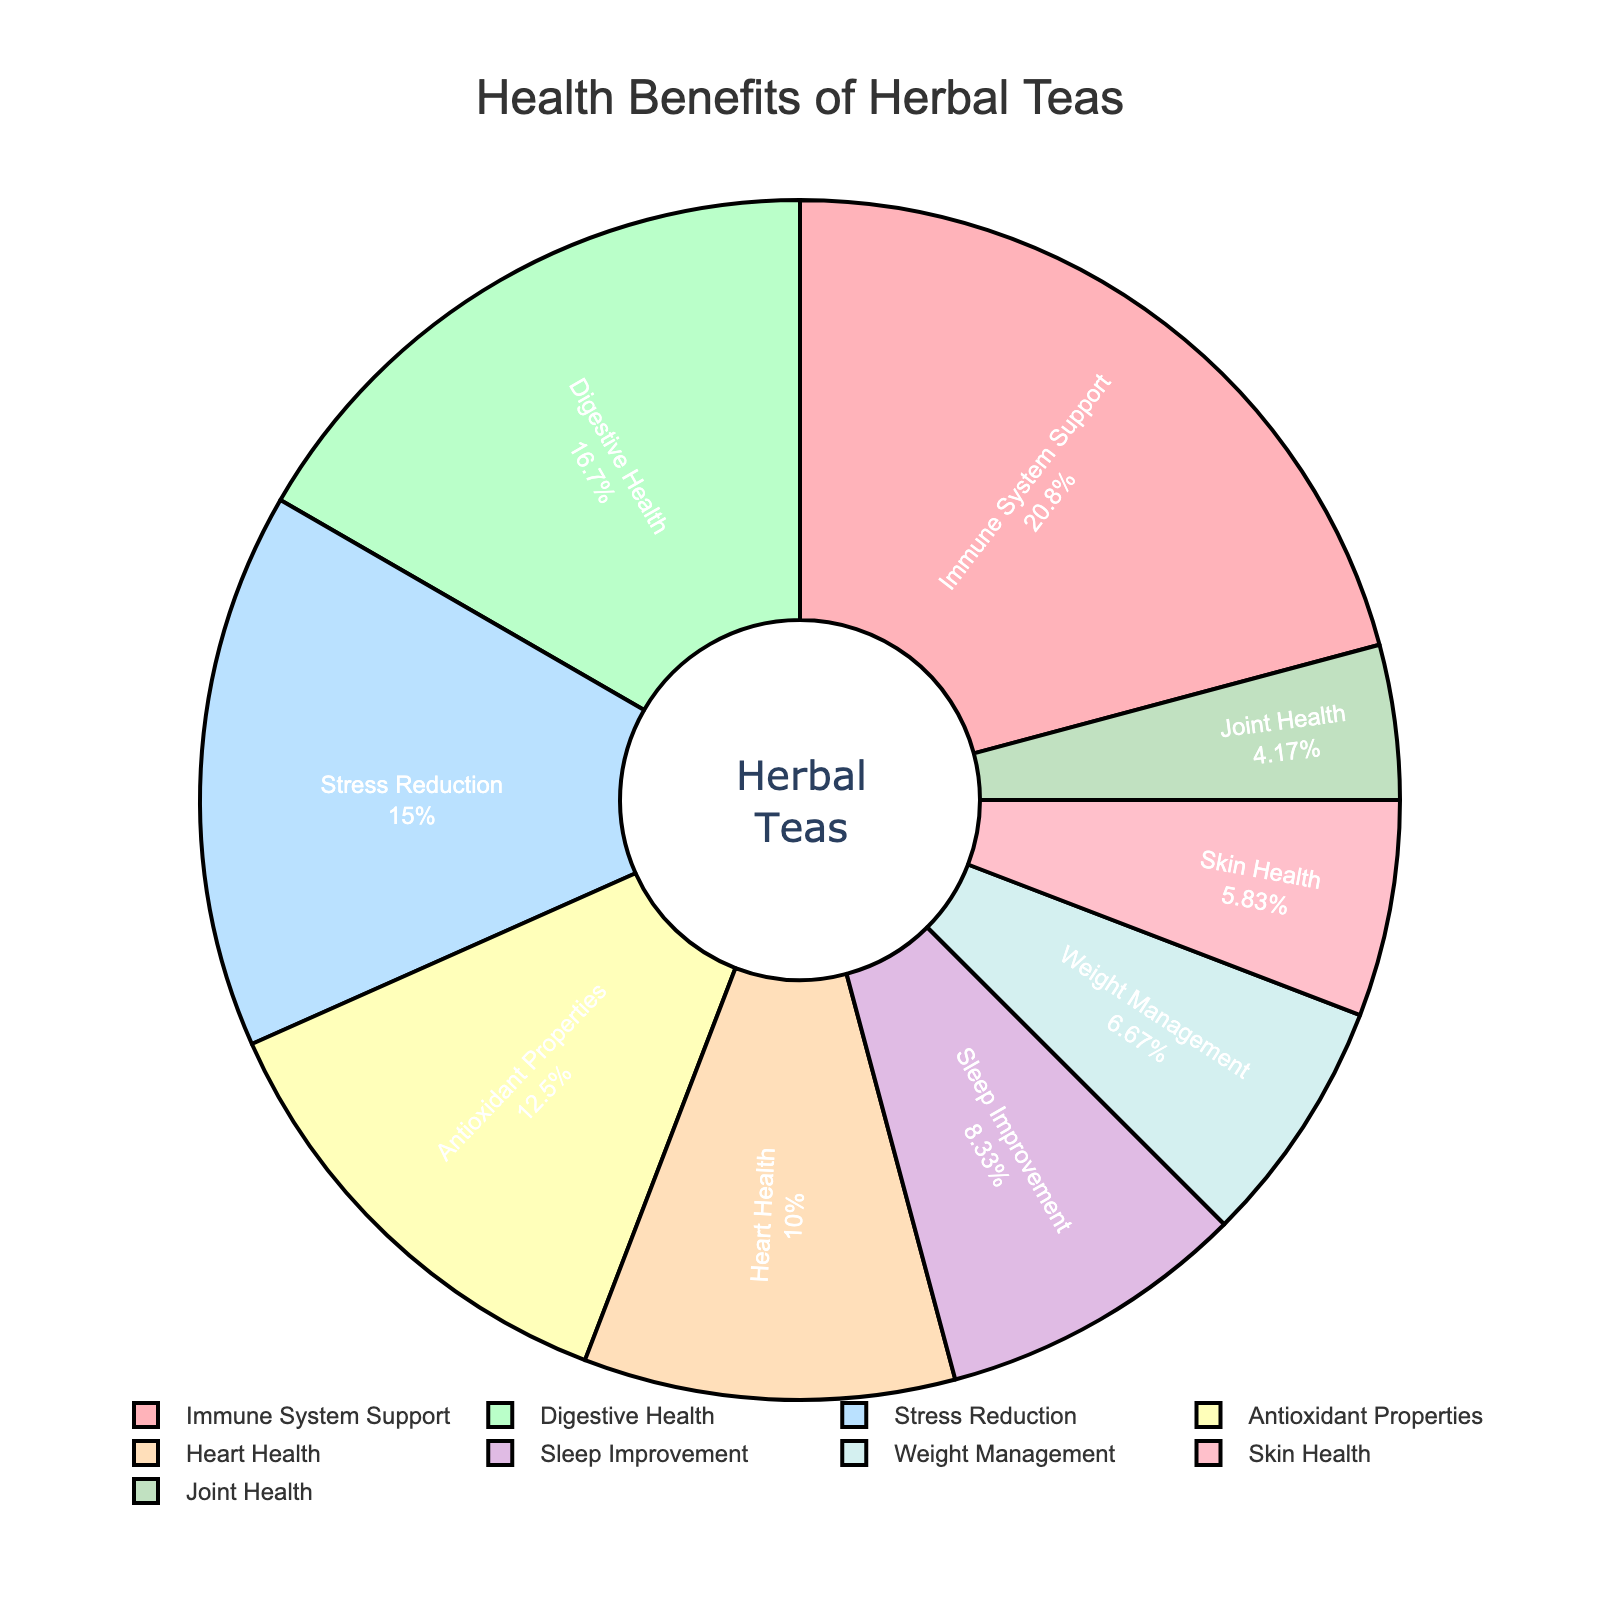What's the largest health benefit category for herbal teas? The category with the highest percentage in the pie chart represents the largest health benefit category. Look for the slice with the biggest area.
Answer: Immune System Support Which two health benefits have nearly equal proportions? Compare the percentages provided in the pie slices to find two categories with similar values.
Answer: Skin Health and Weight Management By how much does Digestive Health exceed Sleep Improvement in percentage? Subtract the percentage of Sleep Improvement from Digestive Health's percentage. Digestive Health is 20%, and Sleep Improvement is 10%. So, 20% - 10% = 10%.
Answer: 10% What percentage of health benefits do Stress Reduction and Heart Health together account for? Add the percentages of Stress Reduction and Heart Health. Stress Reduction is 18% and Heart Health is 12%. So, 18% + 12% = 30%.
Answer: 30% Which health benefit has the smallest proportion? Identify the smallest slice in the pie chart, indicating the lowest percentage.
Answer: Joint Health What is the combined percentage of Antioxidant Properties and Skin Health? Add the percentages of Antioxidant Properties (15%) and Skin Health (7%). So, 15% + 7% = 22%.
Answer: 22% How does the percentage of Immune System Support compare to that of Antioxidant Properties? Compare the slices for Immune System Support (25%) and Antioxidant Properties (15%). 25% is greater than 15%.
Answer: Greater What is the difference in percentage between the highest and lowest health benefit categories? Identify the highest percentage (Immune System Support at 25%) and subtract the lowest percentage (Joint Health at 5%) from it. So, 25% - 5% = 20%.
Answer: 20% What is the percentage share of health benefits that account for less than 10% individually? Identify and sum the categories with less than 10%: Weight Management (8%), Skin Health (7%), Joint Health (5%). So, 8% + 7% + 5% = 20%.
Answer: 20% What health benefits categories together cover more than half of the pie? Analyze the sections of the pie chart that collectively give more than 50%. Immune System Support (25%), Digestive Health (20%), Stress Reduction (18%). Adding these: 25% + 20% + 18% = 63%.
Answer: Immune System Support, Digestive Health, Stress Reduction 